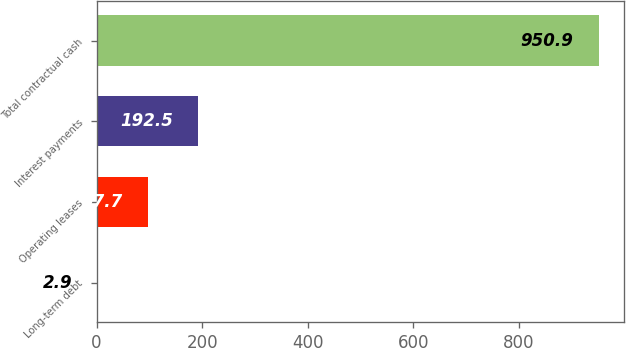Convert chart. <chart><loc_0><loc_0><loc_500><loc_500><bar_chart><fcel>Long-term debt<fcel>Operating leases<fcel>Interest payments<fcel>Total contractual cash<nl><fcel>2.9<fcel>97.7<fcel>192.5<fcel>950.9<nl></chart> 